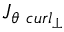<formula> <loc_0><loc_0><loc_500><loc_500>{ J } _ { \theta \ c u r l _ { \perp } }</formula> 